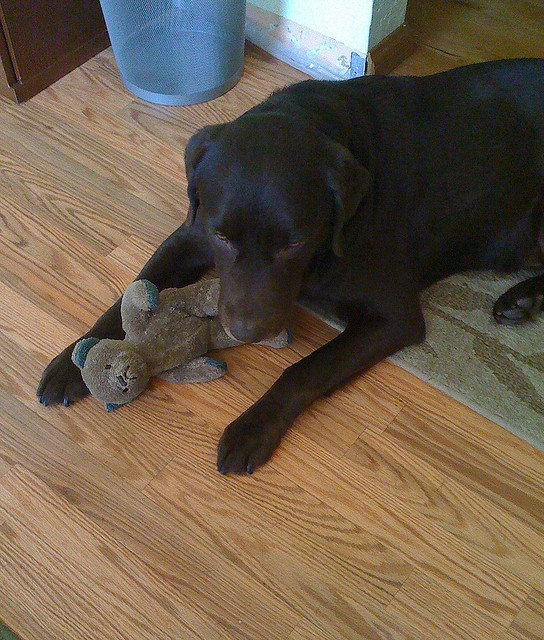Describe the objects in this image and their specific colors. I can see dog in black and gray tones and teddy bear in black and gray tones in this image. 